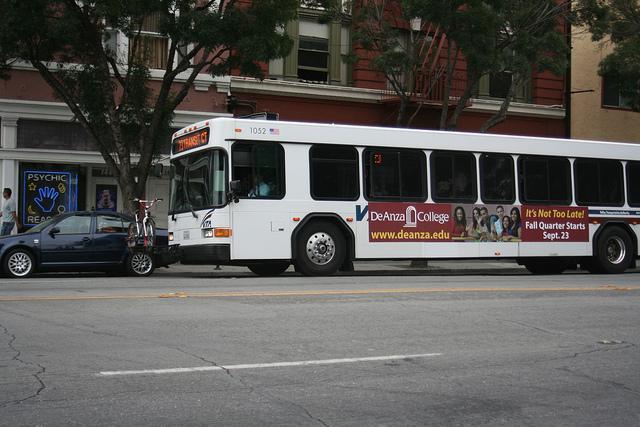Is the given caption "The bus is far away from the bicycle." fitting for the image?
Answer yes or no. No. 